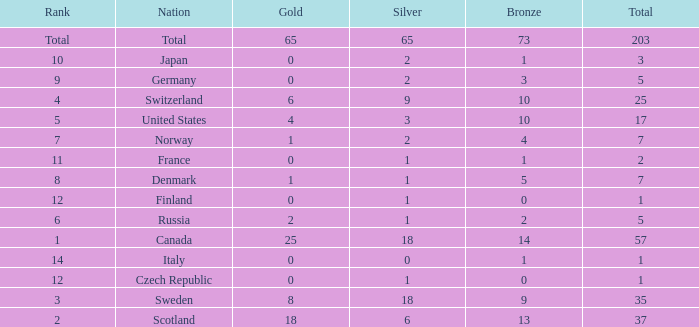What is the total number of medals when there are 18 gold medals? 37.0. 